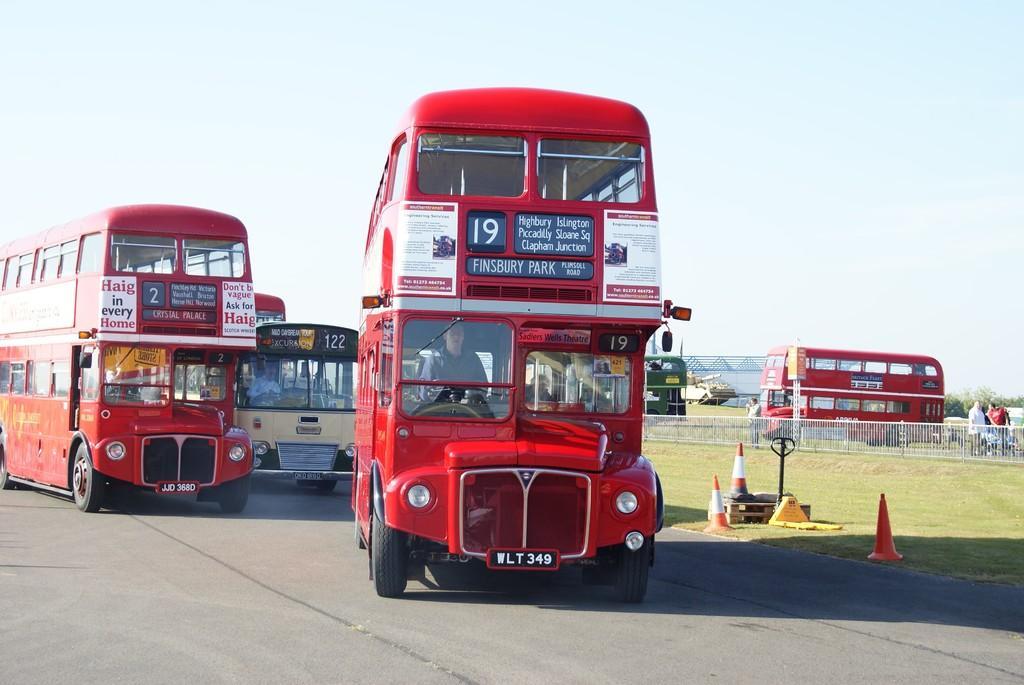Please provide a concise description of this image. This image is taken outdoors. At the top of the image there is a sky. At the bottom of the image there is a road. In the middle of the image a few buses are moving on the road. On the right side of the image there is a ground with grass on it. There are a few safety cones on the ground. There is a railing and two buses are parked on the ground. In the background there are a few trees and a few people are standing on the road. 